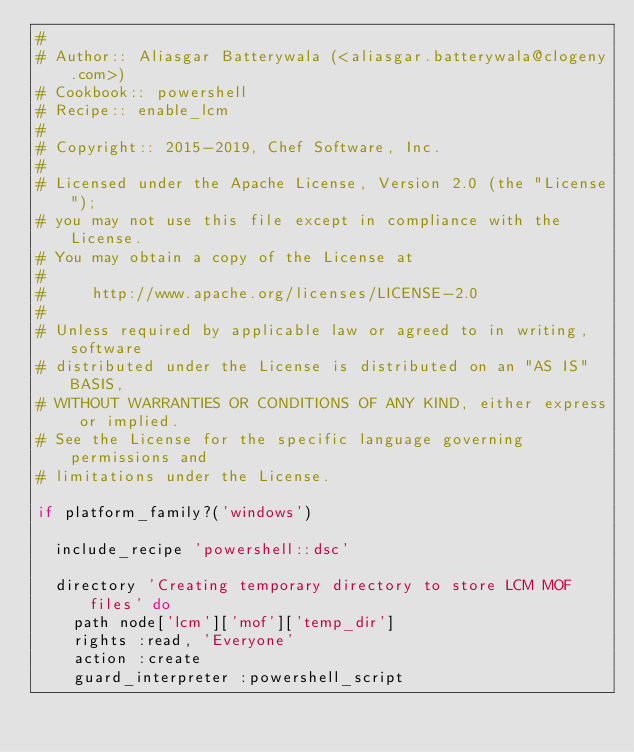Convert code to text. <code><loc_0><loc_0><loc_500><loc_500><_Ruby_>#
# Author:: Aliasgar Batterywala (<aliasgar.batterywala@clogeny.com>)
# Cookbook:: powershell
# Recipe:: enable_lcm
#
# Copyright:: 2015-2019, Chef Software, Inc.
#
# Licensed under the Apache License, Version 2.0 (the "License");
# you may not use this file except in compliance with the License.
# You may obtain a copy of the License at
#
#     http://www.apache.org/licenses/LICENSE-2.0
#
# Unless required by applicable law or agreed to in writing, software
# distributed under the License is distributed on an "AS IS" BASIS,
# WITHOUT WARRANTIES OR CONDITIONS OF ANY KIND, either express or implied.
# See the License for the specific language governing permissions and
# limitations under the License.

if platform_family?('windows')

  include_recipe 'powershell::dsc'

  directory 'Creating temporary directory to store LCM MOF files' do
    path node['lcm']['mof']['temp_dir']
    rights :read, 'Everyone'
    action :create
    guard_interpreter :powershell_script</code> 